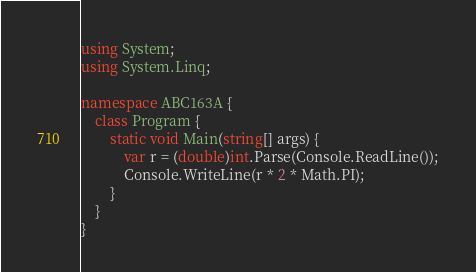Convert code to text. <code><loc_0><loc_0><loc_500><loc_500><_C#_>using System;
using System.Linq;

namespace ABC163A {
    class Program {
        static void Main(string[] args) {
            var r = (double)int.Parse(Console.ReadLine());
            Console.WriteLine(r * 2 * Math.PI);
        }
    }
}</code> 